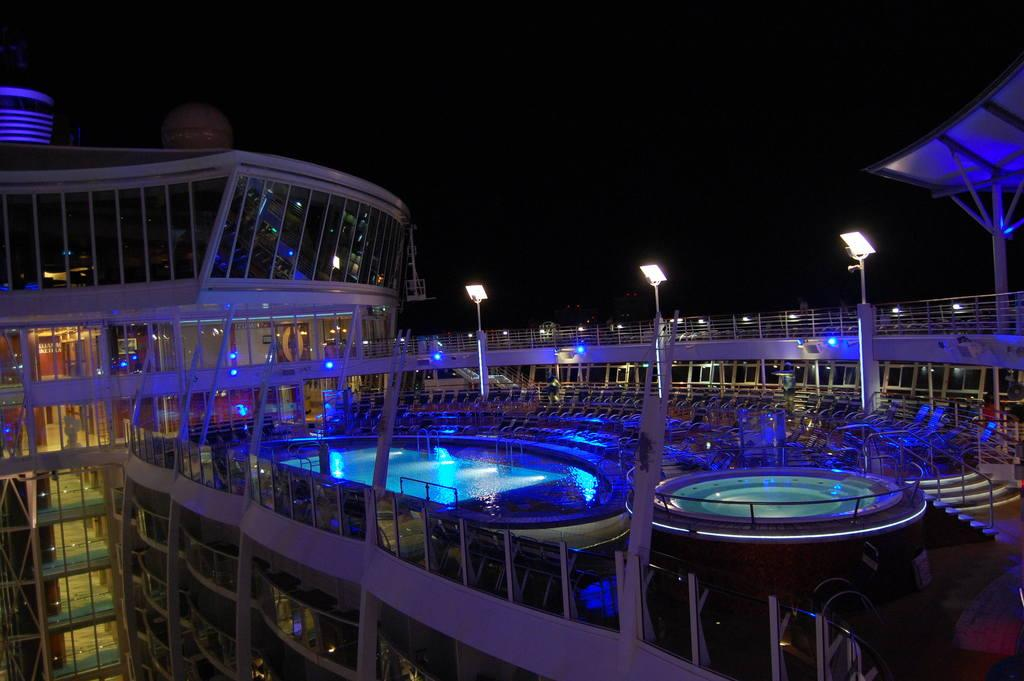What type of structure is present in the image? There is a building in the image. What can be seen illuminated in the image? There are lights visible in the image. What type of barrier is present in the image? There is a fence in the image. What type of recreational feature is present in the image? There is a swimming pool in the image. What type of seating is present in the image? There are chairs in the image. How would you describe the lighting conditions in the image? The background of the image is dark. What type of pickle is being used as a decoration in the image? There is no pickle present in the image; it is not a relevant object or feature. What reason might someone have for being in the building in the image? The image does not provide any information about the purpose or reason for being in the building, so it cannot be determined from the image. 